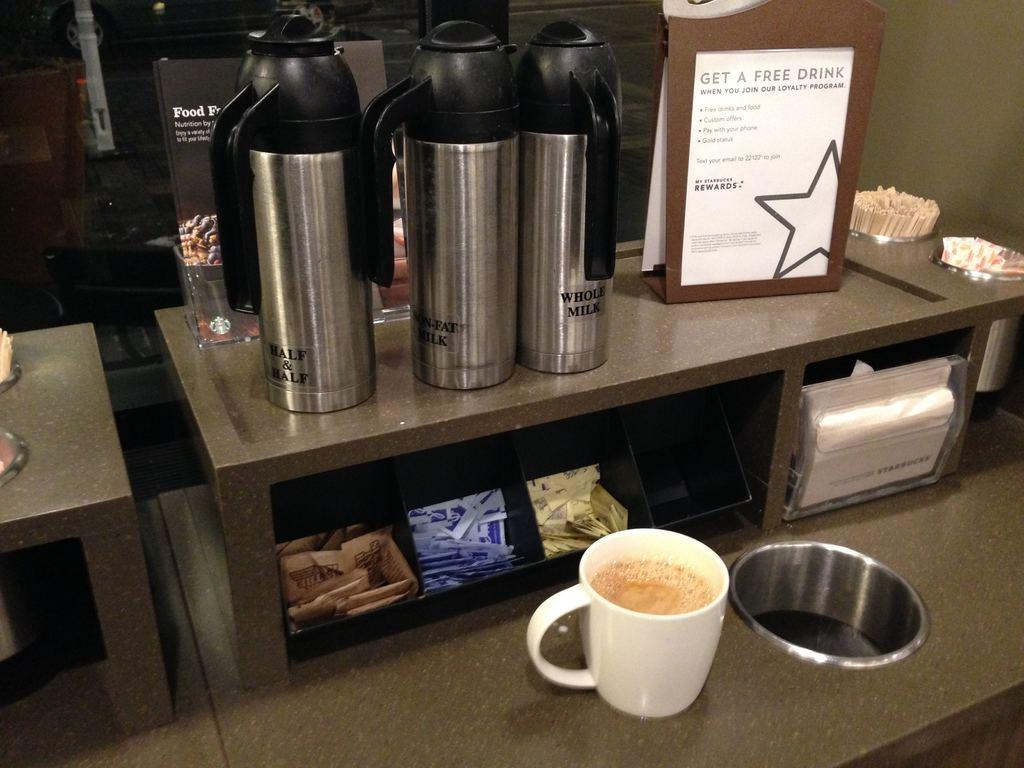What type of bottles are in the image? There are tea infuser bottles in the image. What color is the cup in the image? The cup in the image is white. Can you describe any other objects present in the image? Unfortunately, the provided facts do not give any information about other objects in the image. What type of beef can be seen in the image? There is no beef present in the image. Is the dirt visible in the image? There is no mention of dirt in the provided facts, so it cannot be determined if it is present in the image. --- 